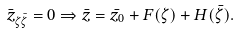Convert formula to latex. <formula><loc_0><loc_0><loc_500><loc_500>\bar { z } _ { \zeta \bar { \zeta } } = 0 \Rightarrow \bar { z } = \bar { z _ { 0 } } + F ( { \zeta } ) + H ( \bar { \zeta } ) .</formula> 